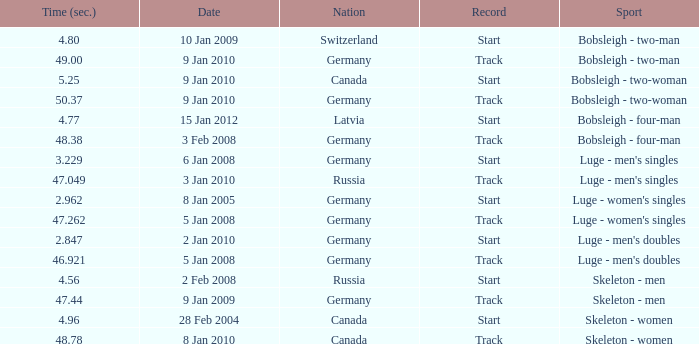Can you give me this table as a dict? {'header': ['Time (sec.)', 'Date', 'Nation', 'Record', 'Sport'], 'rows': [['4.80', '10 Jan 2009', 'Switzerland', 'Start', 'Bobsleigh - two-man'], ['49.00', '9 Jan 2010', 'Germany', 'Track', 'Bobsleigh - two-man'], ['5.25', '9 Jan 2010', 'Canada', 'Start', 'Bobsleigh - two-woman'], ['50.37', '9 Jan 2010', 'Germany', 'Track', 'Bobsleigh - two-woman'], ['4.77', '15 Jan 2012', 'Latvia', 'Start', 'Bobsleigh - four-man'], ['48.38', '3 Feb 2008', 'Germany', 'Track', 'Bobsleigh - four-man'], ['3.229', '6 Jan 2008', 'Germany', 'Start', "Luge - men's singles"], ['47.049', '3 Jan 2010', 'Russia', 'Track', "Luge - men's singles"], ['2.962', '8 Jan 2005', 'Germany', 'Start', "Luge - women's singles"], ['47.262', '5 Jan 2008', 'Germany', 'Track', "Luge - women's singles"], ['2.847', '2 Jan 2010', 'Germany', 'Start', "Luge - men's doubles"], ['46.921', '5 Jan 2008', 'Germany', 'Track', "Luge - men's doubles"], ['4.56', '2 Feb 2008', 'Russia', 'Start', 'Skeleton - men'], ['47.44', '9 Jan 2009', 'Germany', 'Track', 'Skeleton - men'], ['4.96', '28 Feb 2004', 'Canada', 'Start', 'Skeleton - women'], ['48.78', '8 Jan 2010', 'Canada', 'Track', 'Skeleton - women']]} Which country had a duration of 4 Germany. 